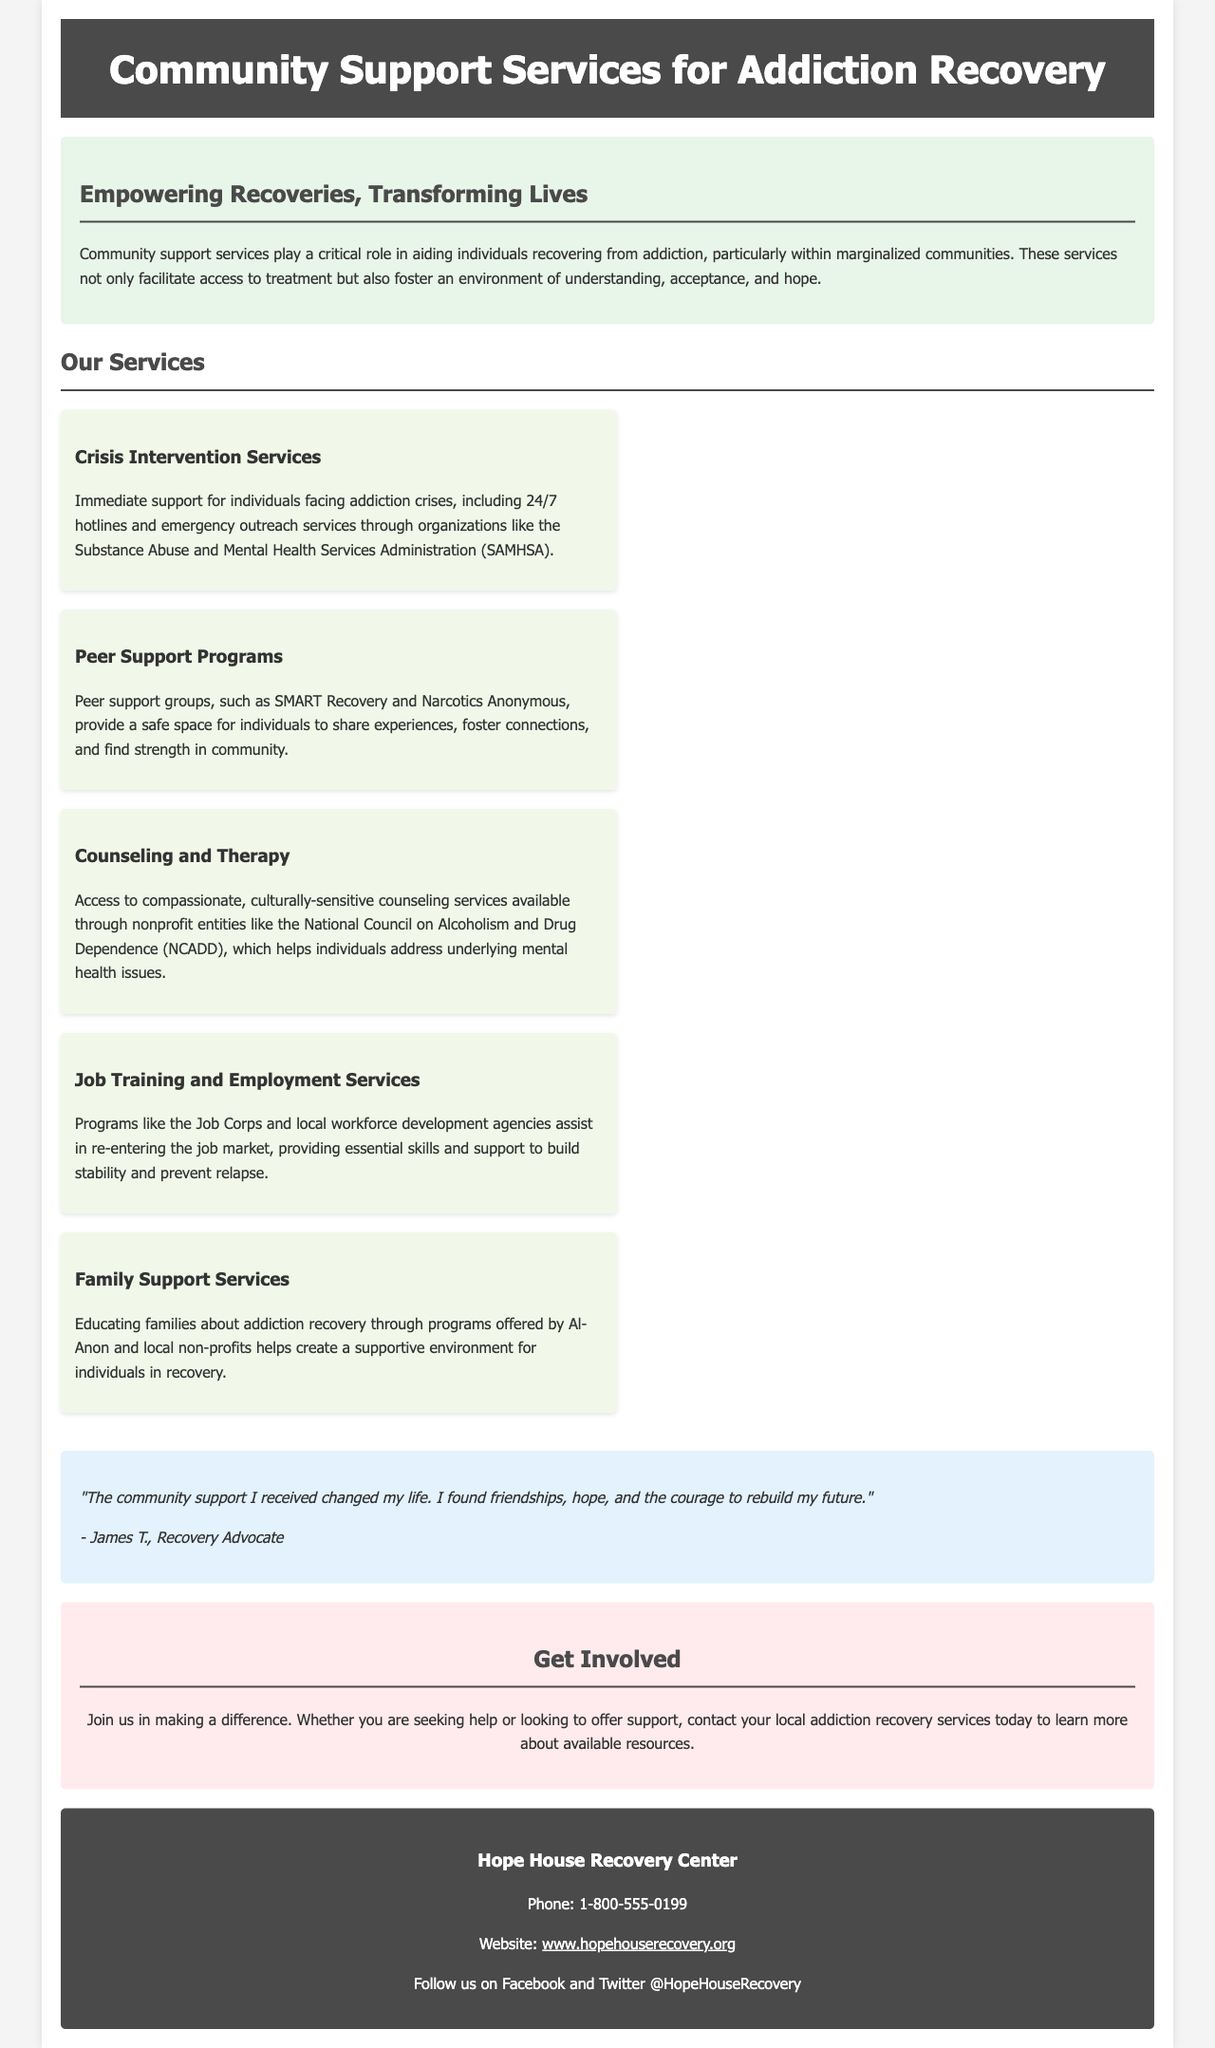What is the name of the recovery center? The recovery center mentioned in the document is Hope House Recovery Center.
Answer: Hope House Recovery Center What is the phone number for the recovery center? The phone number provided for the recovery center is listed in the contact section.
Answer: 1-800-555-0199 What services are offered under "Job Training and Employment Services"? The document states that job training programs assist in re-entering the job market.
Answer: Job Corps and local workforce development agencies What is the focus of "Crisis Intervention Services"? This service includes immediate support for individuals facing addiction crises.
Answer: 24/7 hotlines and emergency outreach services How does the document describe peer support programs? Peer support programs are defined as providing a safe space for individuals to share experiences and foster connections.
Answer: Safe space for sharing experiences What type of support do family services provide? Family support services are focused on educating families about addiction recovery.
Answer: Educating families about addiction recovery Who is the testimonial attributed to? The testimonial included in the brochure is attributed to a recovery advocate.
Answer: James T., Recovery Advocate What is the main theme of the introduction section? The introduction emphasizes the critical role of community support services in addiction recovery.
Answer: Empowering Recoveries, Transforming Lives 